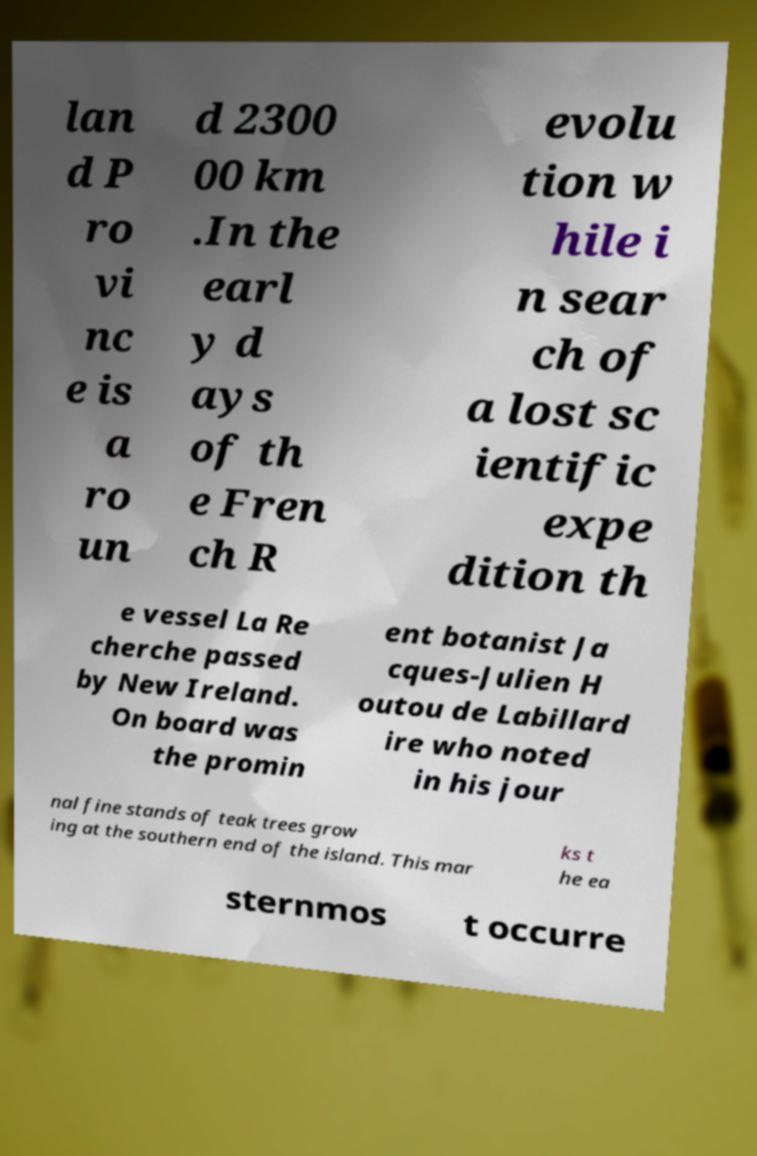Could you extract and type out the text from this image? lan d P ro vi nc e is a ro un d 2300 00 km .In the earl y d ays of th e Fren ch R evolu tion w hile i n sear ch of a lost sc ientific expe dition th e vessel La Re cherche passed by New Ireland. On board was the promin ent botanist Ja cques-Julien H outou de Labillard ire who noted in his jour nal fine stands of teak trees grow ing at the southern end of the island. This mar ks t he ea sternmos t occurre 